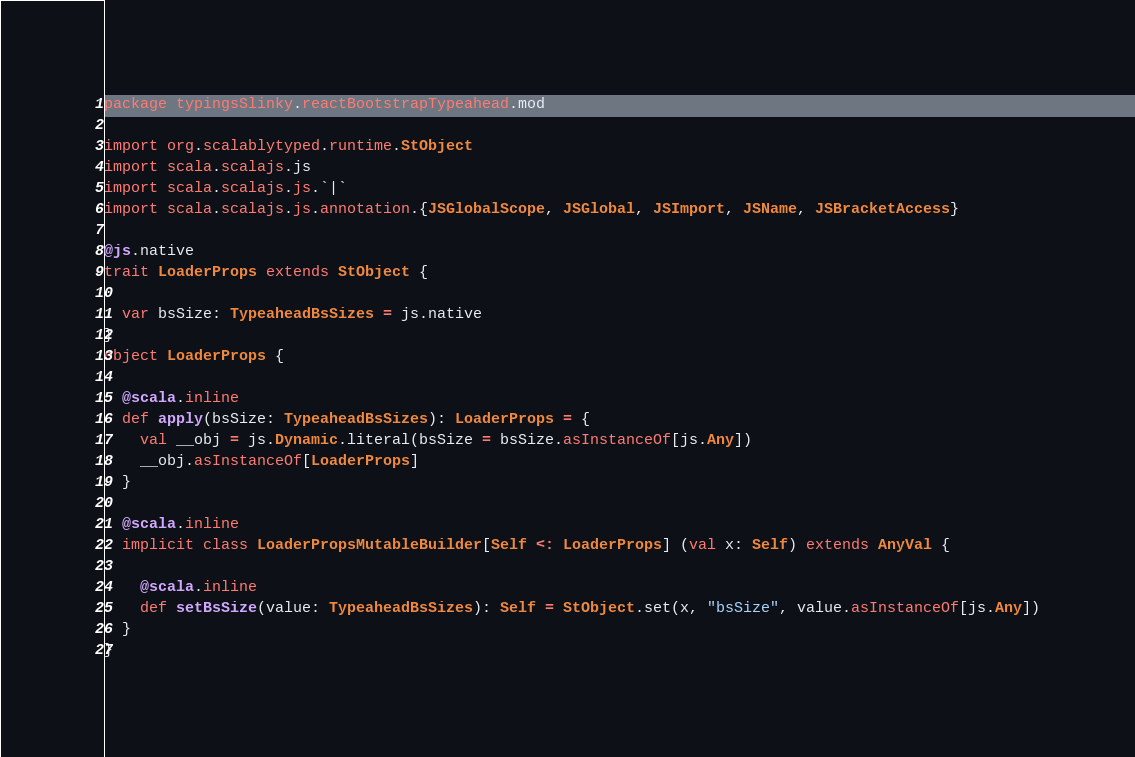Convert code to text. <code><loc_0><loc_0><loc_500><loc_500><_Scala_>package typingsSlinky.reactBootstrapTypeahead.mod

import org.scalablytyped.runtime.StObject
import scala.scalajs.js
import scala.scalajs.js.`|`
import scala.scalajs.js.annotation.{JSGlobalScope, JSGlobal, JSImport, JSName, JSBracketAccess}

@js.native
trait LoaderProps extends StObject {
  
  var bsSize: TypeaheadBsSizes = js.native
}
object LoaderProps {
  
  @scala.inline
  def apply(bsSize: TypeaheadBsSizes): LoaderProps = {
    val __obj = js.Dynamic.literal(bsSize = bsSize.asInstanceOf[js.Any])
    __obj.asInstanceOf[LoaderProps]
  }
  
  @scala.inline
  implicit class LoaderPropsMutableBuilder[Self <: LoaderProps] (val x: Self) extends AnyVal {
    
    @scala.inline
    def setBsSize(value: TypeaheadBsSizes): Self = StObject.set(x, "bsSize", value.asInstanceOf[js.Any])
  }
}
</code> 